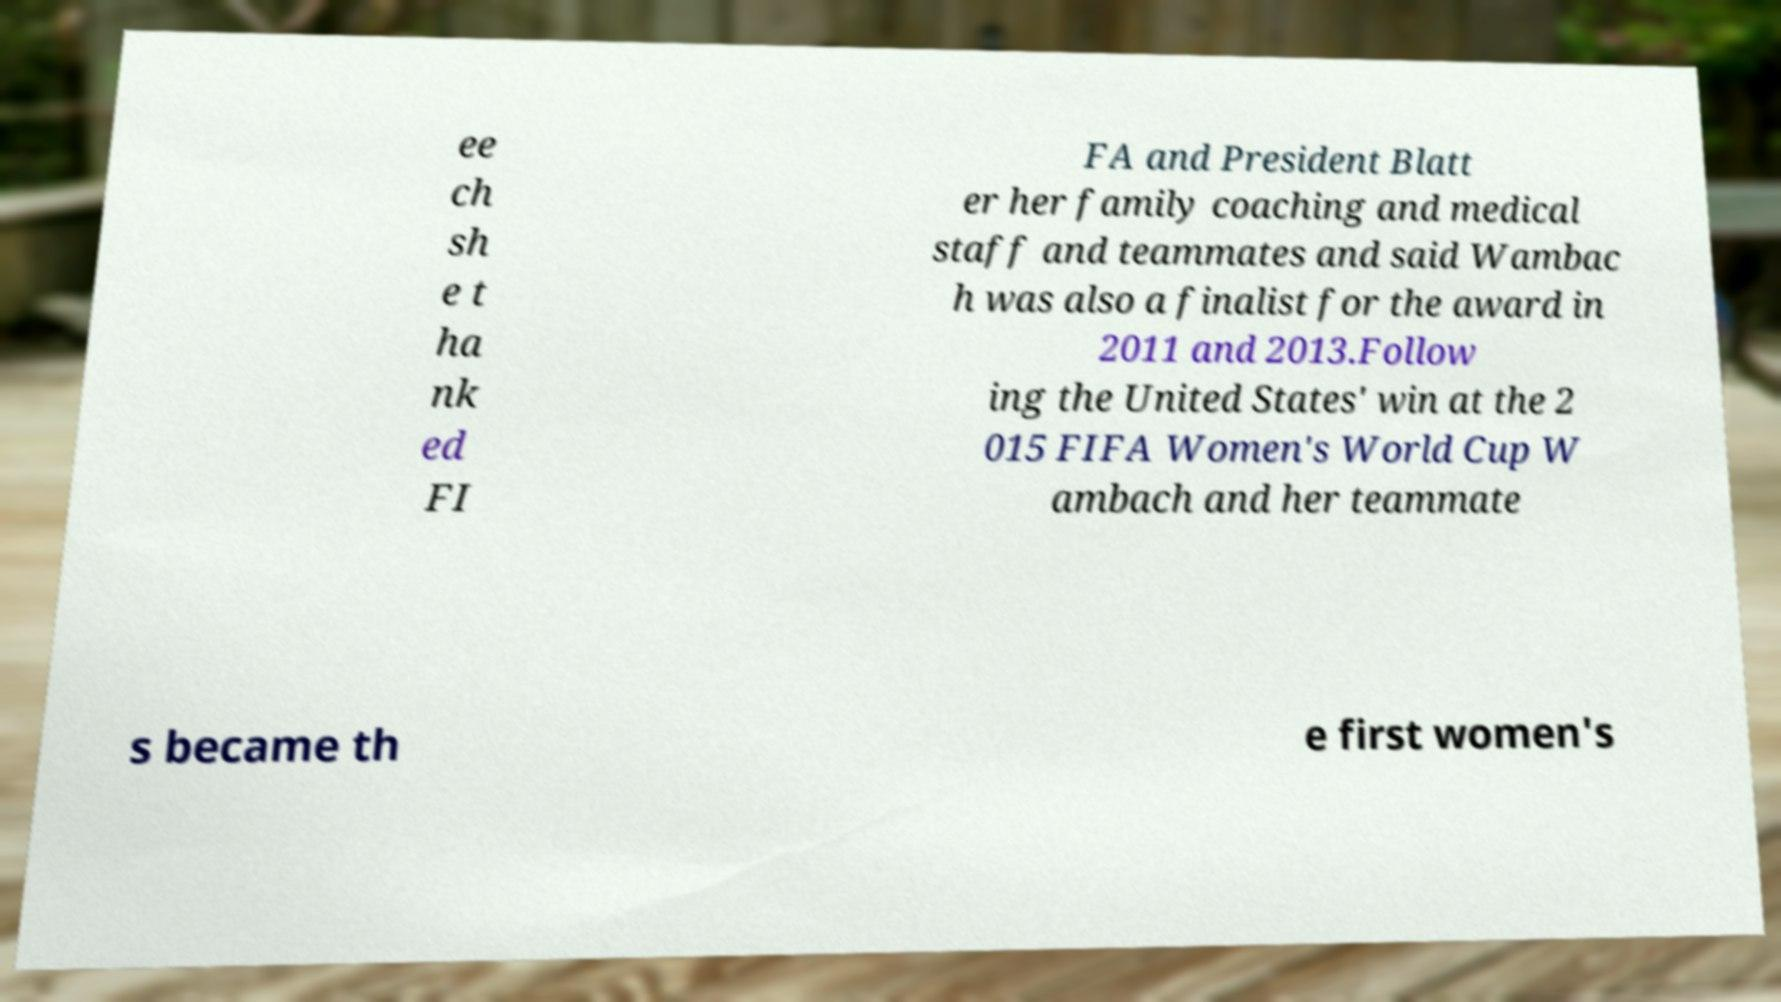Can you read and provide the text displayed in the image?This photo seems to have some interesting text. Can you extract and type it out for me? ee ch sh e t ha nk ed FI FA and President Blatt er her family coaching and medical staff and teammates and said Wambac h was also a finalist for the award in 2011 and 2013.Follow ing the United States' win at the 2 015 FIFA Women's World Cup W ambach and her teammate s became th e first women's 